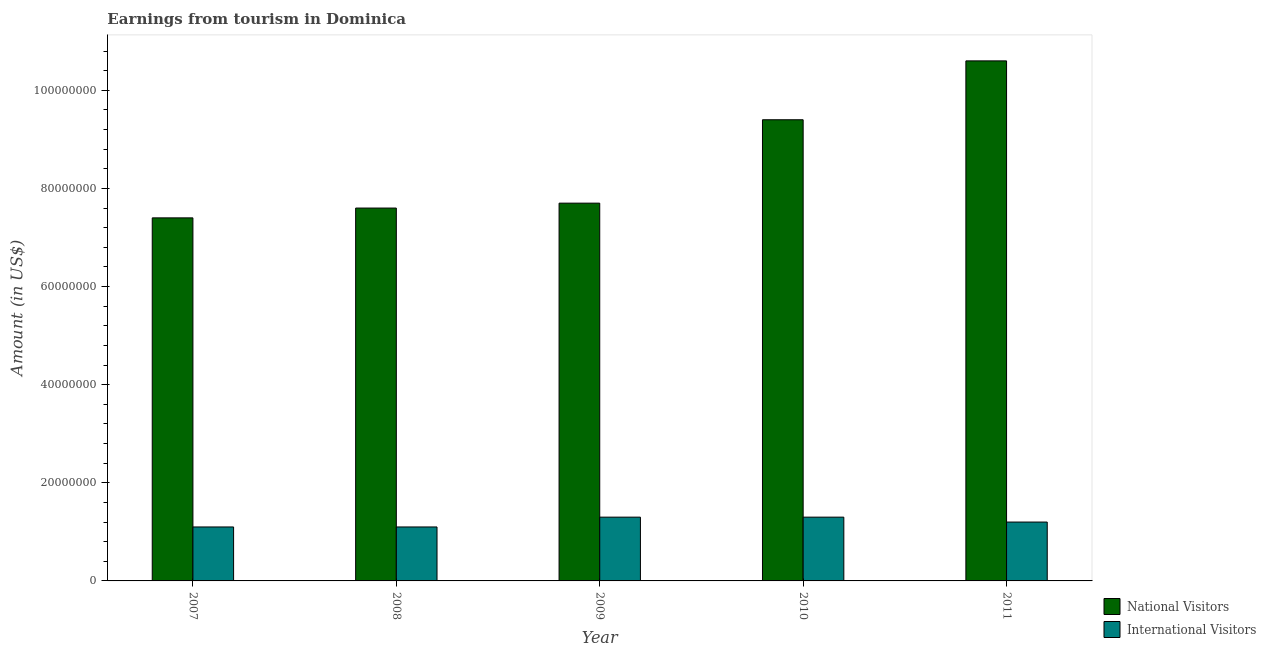How many groups of bars are there?
Provide a succinct answer. 5. Are the number of bars per tick equal to the number of legend labels?
Your response must be concise. Yes. How many bars are there on the 1st tick from the left?
Offer a very short reply. 2. How many bars are there on the 5th tick from the right?
Provide a succinct answer. 2. What is the amount earned from national visitors in 2008?
Offer a very short reply. 7.60e+07. Across all years, what is the maximum amount earned from international visitors?
Offer a very short reply. 1.30e+07. Across all years, what is the minimum amount earned from national visitors?
Your response must be concise. 7.40e+07. In which year was the amount earned from international visitors minimum?
Your answer should be compact. 2007. What is the total amount earned from international visitors in the graph?
Your answer should be compact. 6.00e+07. What is the difference between the amount earned from international visitors in 2009 and that in 2010?
Provide a succinct answer. 0. What is the difference between the amount earned from international visitors in 2011 and the amount earned from national visitors in 2009?
Give a very brief answer. -1.00e+06. What is the average amount earned from international visitors per year?
Make the answer very short. 1.20e+07. In how many years, is the amount earned from national visitors greater than 96000000 US$?
Your answer should be very brief. 1. What is the ratio of the amount earned from national visitors in 2008 to that in 2011?
Provide a short and direct response. 0.72. What is the difference between the highest and the lowest amount earned from international visitors?
Give a very brief answer. 2.00e+06. In how many years, is the amount earned from national visitors greater than the average amount earned from national visitors taken over all years?
Give a very brief answer. 2. What does the 2nd bar from the left in 2011 represents?
Provide a succinct answer. International Visitors. What does the 1st bar from the right in 2011 represents?
Keep it short and to the point. International Visitors. How many bars are there?
Your answer should be compact. 10. Are all the bars in the graph horizontal?
Your response must be concise. No. How many years are there in the graph?
Make the answer very short. 5. Does the graph contain any zero values?
Make the answer very short. No. Where does the legend appear in the graph?
Your answer should be compact. Bottom right. How are the legend labels stacked?
Ensure brevity in your answer.  Vertical. What is the title of the graph?
Ensure brevity in your answer.  Earnings from tourism in Dominica. Does "Boys" appear as one of the legend labels in the graph?
Provide a succinct answer. No. What is the Amount (in US$) in National Visitors in 2007?
Offer a terse response. 7.40e+07. What is the Amount (in US$) in International Visitors in 2007?
Offer a terse response. 1.10e+07. What is the Amount (in US$) of National Visitors in 2008?
Keep it short and to the point. 7.60e+07. What is the Amount (in US$) in International Visitors in 2008?
Give a very brief answer. 1.10e+07. What is the Amount (in US$) of National Visitors in 2009?
Your answer should be compact. 7.70e+07. What is the Amount (in US$) of International Visitors in 2009?
Your response must be concise. 1.30e+07. What is the Amount (in US$) of National Visitors in 2010?
Your response must be concise. 9.40e+07. What is the Amount (in US$) in International Visitors in 2010?
Your response must be concise. 1.30e+07. What is the Amount (in US$) of National Visitors in 2011?
Give a very brief answer. 1.06e+08. What is the Amount (in US$) in International Visitors in 2011?
Ensure brevity in your answer.  1.20e+07. Across all years, what is the maximum Amount (in US$) of National Visitors?
Your response must be concise. 1.06e+08. Across all years, what is the maximum Amount (in US$) in International Visitors?
Make the answer very short. 1.30e+07. Across all years, what is the minimum Amount (in US$) of National Visitors?
Offer a terse response. 7.40e+07. Across all years, what is the minimum Amount (in US$) of International Visitors?
Provide a succinct answer. 1.10e+07. What is the total Amount (in US$) of National Visitors in the graph?
Offer a terse response. 4.27e+08. What is the total Amount (in US$) of International Visitors in the graph?
Ensure brevity in your answer.  6.00e+07. What is the difference between the Amount (in US$) in National Visitors in 2007 and that in 2010?
Offer a very short reply. -2.00e+07. What is the difference between the Amount (in US$) in National Visitors in 2007 and that in 2011?
Ensure brevity in your answer.  -3.20e+07. What is the difference between the Amount (in US$) of International Visitors in 2007 and that in 2011?
Your response must be concise. -1.00e+06. What is the difference between the Amount (in US$) in National Visitors in 2008 and that in 2009?
Offer a very short reply. -1.00e+06. What is the difference between the Amount (in US$) in National Visitors in 2008 and that in 2010?
Provide a short and direct response. -1.80e+07. What is the difference between the Amount (in US$) of International Visitors in 2008 and that in 2010?
Offer a very short reply. -2.00e+06. What is the difference between the Amount (in US$) in National Visitors in 2008 and that in 2011?
Offer a very short reply. -3.00e+07. What is the difference between the Amount (in US$) in National Visitors in 2009 and that in 2010?
Keep it short and to the point. -1.70e+07. What is the difference between the Amount (in US$) of National Visitors in 2009 and that in 2011?
Ensure brevity in your answer.  -2.90e+07. What is the difference between the Amount (in US$) in National Visitors in 2010 and that in 2011?
Make the answer very short. -1.20e+07. What is the difference between the Amount (in US$) in National Visitors in 2007 and the Amount (in US$) in International Visitors in 2008?
Provide a succinct answer. 6.30e+07. What is the difference between the Amount (in US$) in National Visitors in 2007 and the Amount (in US$) in International Visitors in 2009?
Your response must be concise. 6.10e+07. What is the difference between the Amount (in US$) in National Visitors in 2007 and the Amount (in US$) in International Visitors in 2010?
Your response must be concise. 6.10e+07. What is the difference between the Amount (in US$) in National Visitors in 2007 and the Amount (in US$) in International Visitors in 2011?
Your response must be concise. 6.20e+07. What is the difference between the Amount (in US$) in National Visitors in 2008 and the Amount (in US$) in International Visitors in 2009?
Make the answer very short. 6.30e+07. What is the difference between the Amount (in US$) in National Visitors in 2008 and the Amount (in US$) in International Visitors in 2010?
Offer a very short reply. 6.30e+07. What is the difference between the Amount (in US$) in National Visitors in 2008 and the Amount (in US$) in International Visitors in 2011?
Offer a terse response. 6.40e+07. What is the difference between the Amount (in US$) of National Visitors in 2009 and the Amount (in US$) of International Visitors in 2010?
Keep it short and to the point. 6.40e+07. What is the difference between the Amount (in US$) of National Visitors in 2009 and the Amount (in US$) of International Visitors in 2011?
Keep it short and to the point. 6.50e+07. What is the difference between the Amount (in US$) in National Visitors in 2010 and the Amount (in US$) in International Visitors in 2011?
Offer a very short reply. 8.20e+07. What is the average Amount (in US$) in National Visitors per year?
Provide a succinct answer. 8.54e+07. In the year 2007, what is the difference between the Amount (in US$) in National Visitors and Amount (in US$) in International Visitors?
Provide a succinct answer. 6.30e+07. In the year 2008, what is the difference between the Amount (in US$) of National Visitors and Amount (in US$) of International Visitors?
Your answer should be very brief. 6.50e+07. In the year 2009, what is the difference between the Amount (in US$) in National Visitors and Amount (in US$) in International Visitors?
Provide a succinct answer. 6.40e+07. In the year 2010, what is the difference between the Amount (in US$) of National Visitors and Amount (in US$) of International Visitors?
Offer a terse response. 8.10e+07. In the year 2011, what is the difference between the Amount (in US$) of National Visitors and Amount (in US$) of International Visitors?
Give a very brief answer. 9.40e+07. What is the ratio of the Amount (in US$) of National Visitors in 2007 to that in 2008?
Keep it short and to the point. 0.97. What is the ratio of the Amount (in US$) in National Visitors in 2007 to that in 2009?
Your response must be concise. 0.96. What is the ratio of the Amount (in US$) in International Visitors in 2007 to that in 2009?
Ensure brevity in your answer.  0.85. What is the ratio of the Amount (in US$) of National Visitors in 2007 to that in 2010?
Make the answer very short. 0.79. What is the ratio of the Amount (in US$) of International Visitors in 2007 to that in 2010?
Your response must be concise. 0.85. What is the ratio of the Amount (in US$) of National Visitors in 2007 to that in 2011?
Make the answer very short. 0.7. What is the ratio of the Amount (in US$) in International Visitors in 2007 to that in 2011?
Keep it short and to the point. 0.92. What is the ratio of the Amount (in US$) of National Visitors in 2008 to that in 2009?
Provide a succinct answer. 0.99. What is the ratio of the Amount (in US$) in International Visitors in 2008 to that in 2009?
Your answer should be very brief. 0.85. What is the ratio of the Amount (in US$) of National Visitors in 2008 to that in 2010?
Offer a terse response. 0.81. What is the ratio of the Amount (in US$) in International Visitors in 2008 to that in 2010?
Ensure brevity in your answer.  0.85. What is the ratio of the Amount (in US$) in National Visitors in 2008 to that in 2011?
Offer a terse response. 0.72. What is the ratio of the Amount (in US$) in National Visitors in 2009 to that in 2010?
Your answer should be compact. 0.82. What is the ratio of the Amount (in US$) in National Visitors in 2009 to that in 2011?
Offer a terse response. 0.73. What is the ratio of the Amount (in US$) of National Visitors in 2010 to that in 2011?
Your answer should be very brief. 0.89. What is the ratio of the Amount (in US$) of International Visitors in 2010 to that in 2011?
Provide a succinct answer. 1.08. What is the difference between the highest and the second highest Amount (in US$) in International Visitors?
Provide a short and direct response. 0. What is the difference between the highest and the lowest Amount (in US$) of National Visitors?
Ensure brevity in your answer.  3.20e+07. What is the difference between the highest and the lowest Amount (in US$) in International Visitors?
Your answer should be very brief. 2.00e+06. 